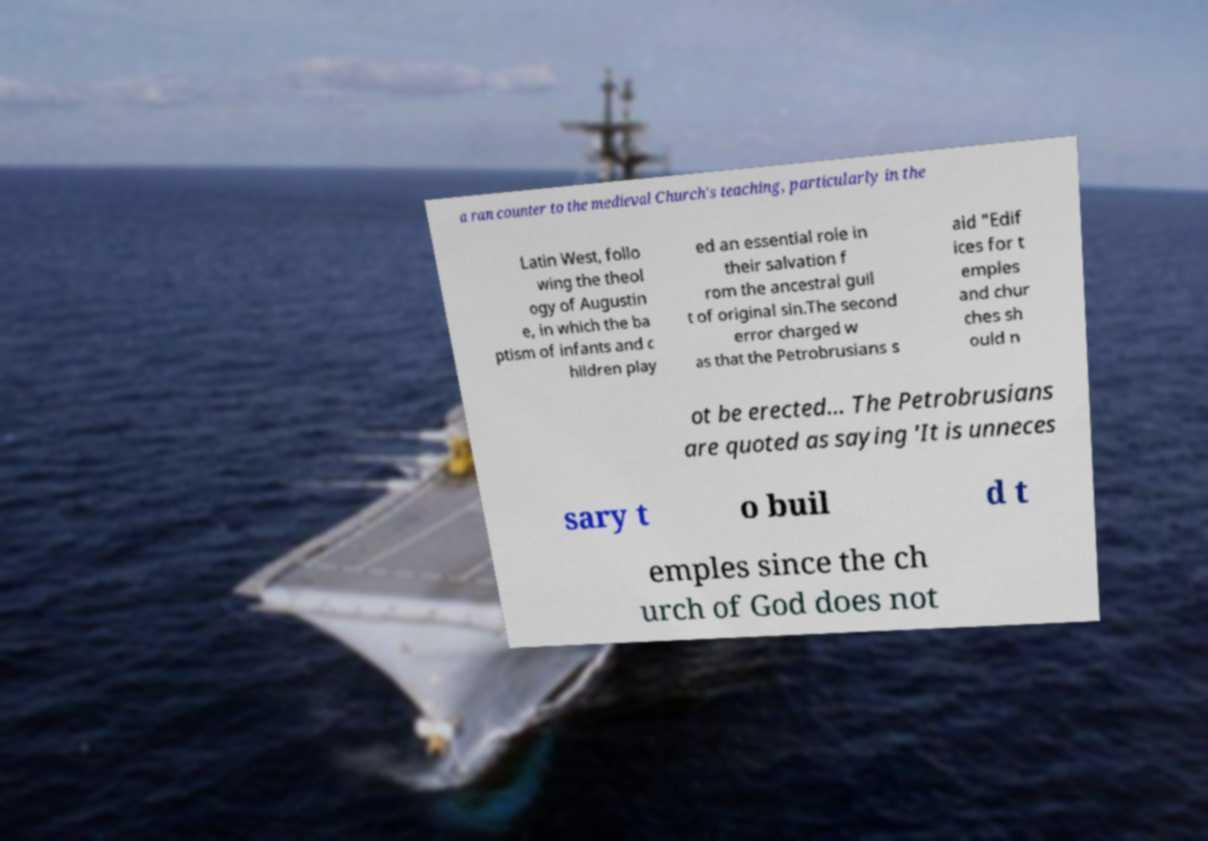Please identify and transcribe the text found in this image. a ran counter to the medieval Church's teaching, particularly in the Latin West, follo wing the theol ogy of Augustin e, in which the ba ptism of infants and c hildren play ed an essential role in their salvation f rom the ancestral guil t of original sin.The second error charged w as that the Petrobrusians s aid "Edif ices for t emples and chur ches sh ould n ot be erected... The Petrobrusians are quoted as saying 'It is unneces sary t o buil d t emples since the ch urch of God does not 